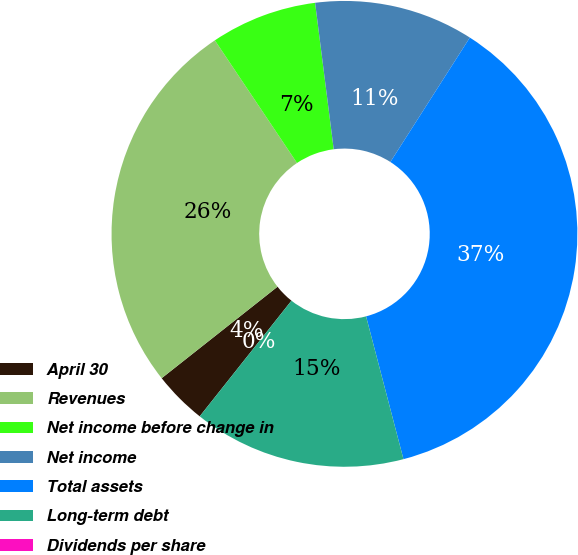<chart> <loc_0><loc_0><loc_500><loc_500><pie_chart><fcel>April 30<fcel>Revenues<fcel>Net income before change in<fcel>Net income<fcel>Total assets<fcel>Long-term debt<fcel>Dividends per share<nl><fcel>3.69%<fcel>26.25%<fcel>7.38%<fcel>11.06%<fcel>36.88%<fcel>14.75%<fcel>0.0%<nl></chart> 